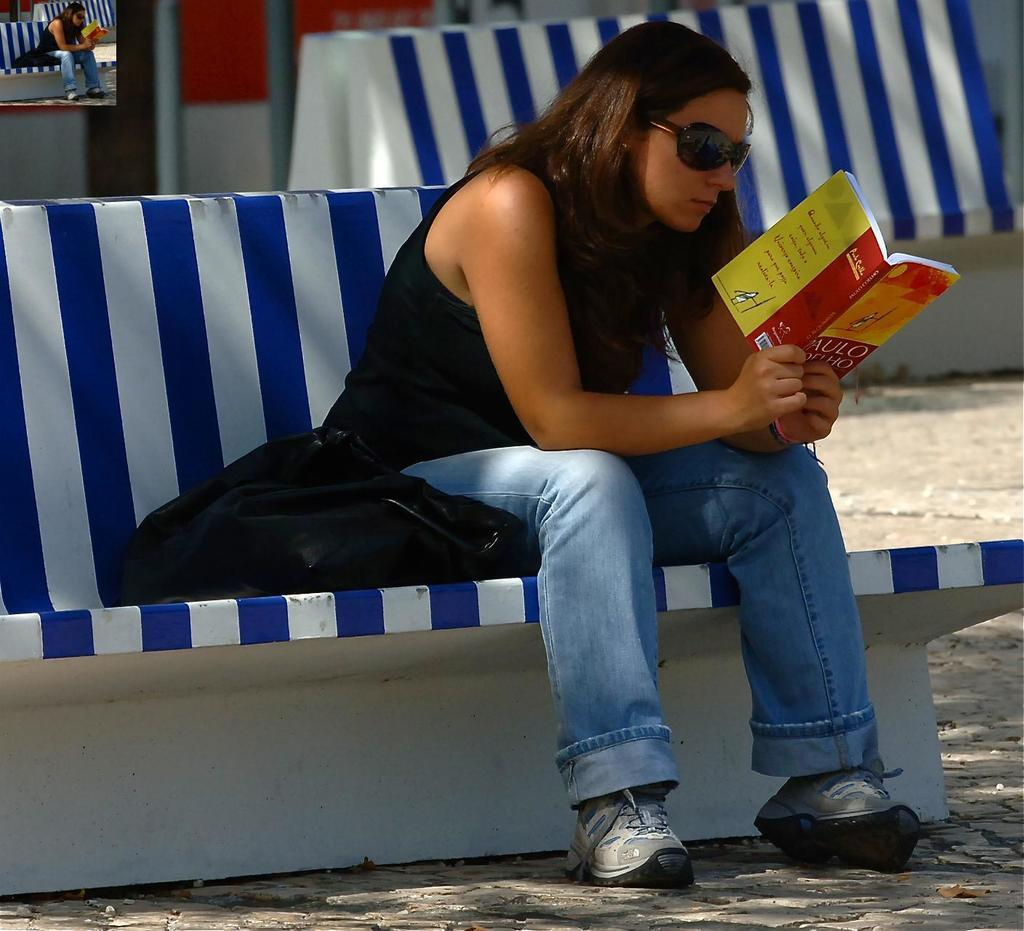<image>
Summarize the visual content of the image. A woman is sitting on a bench reading a book, where part of the book's title 'Aulo' can be seen. 